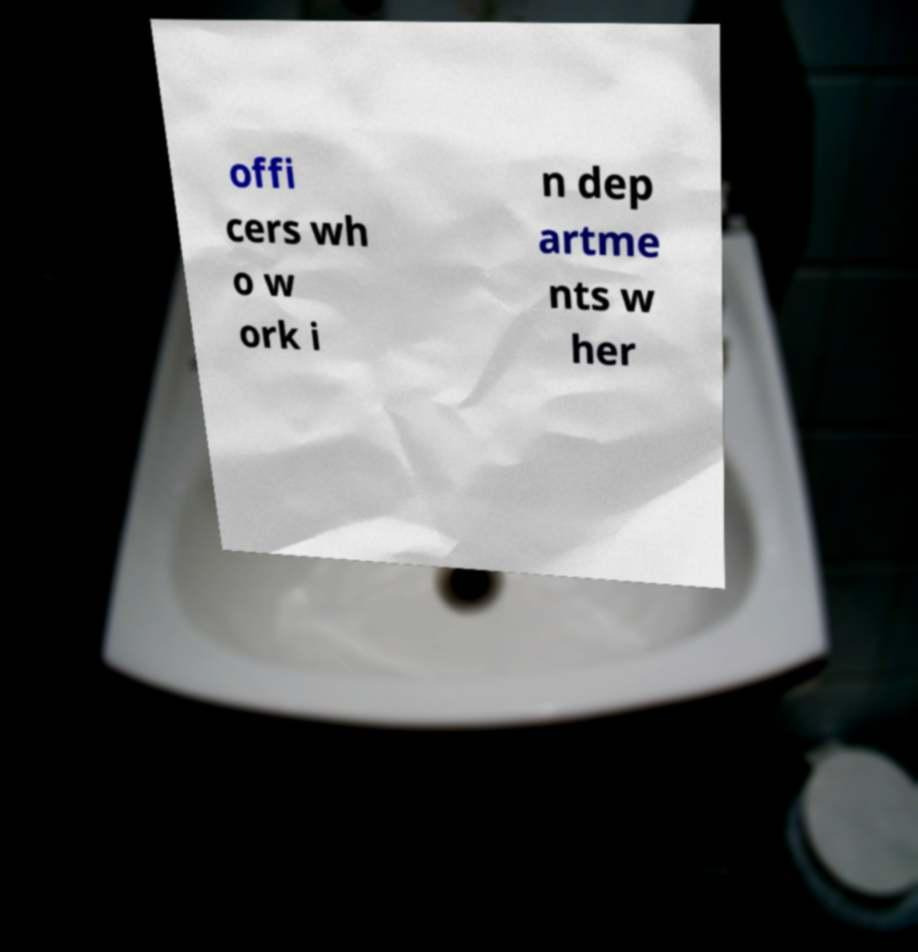I need the written content from this picture converted into text. Can you do that? offi cers wh o w ork i n dep artme nts w her 